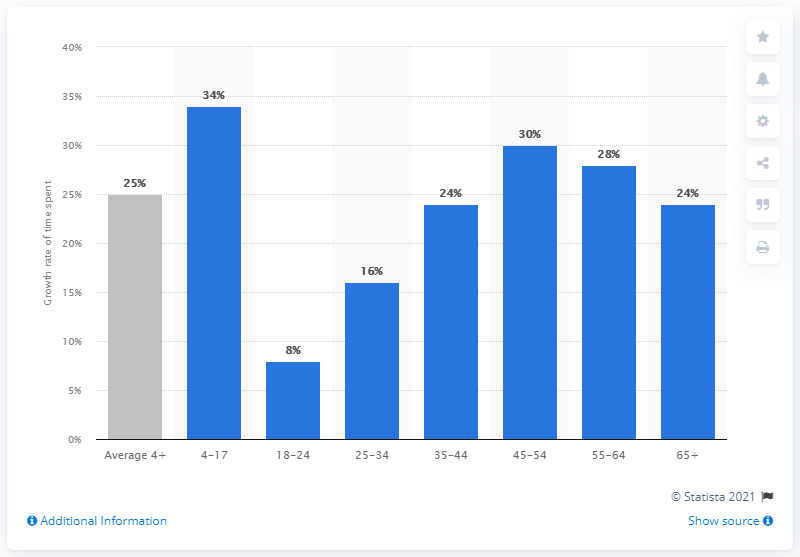Mention a couple of crucial points in this snapshot. In April 2020, the average time spent watching TV increased by 25 minutes compared to the previous year. 